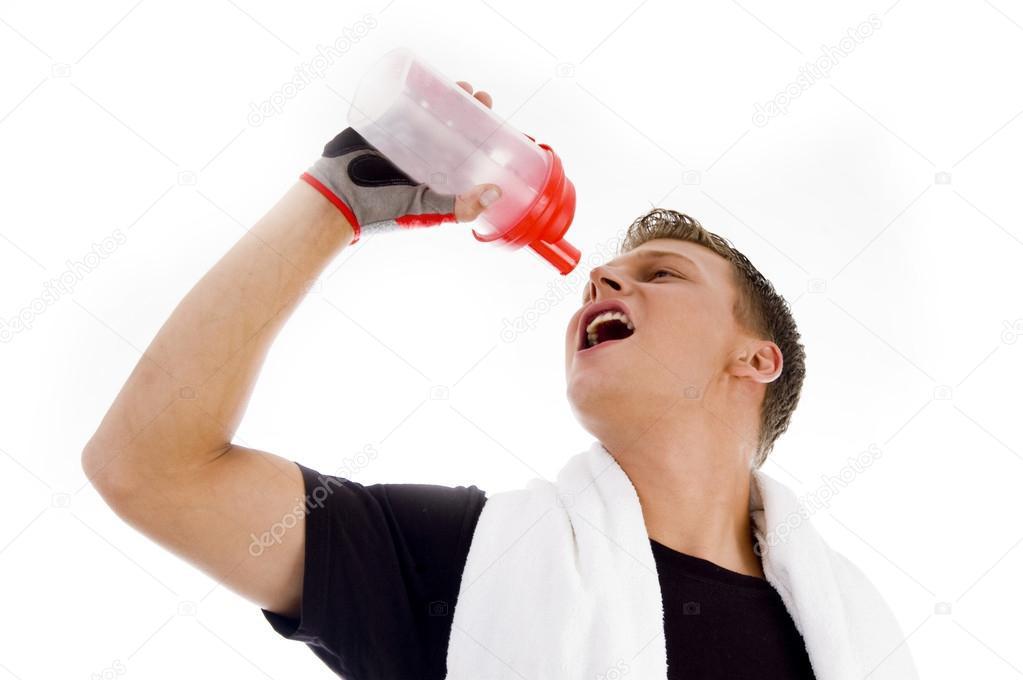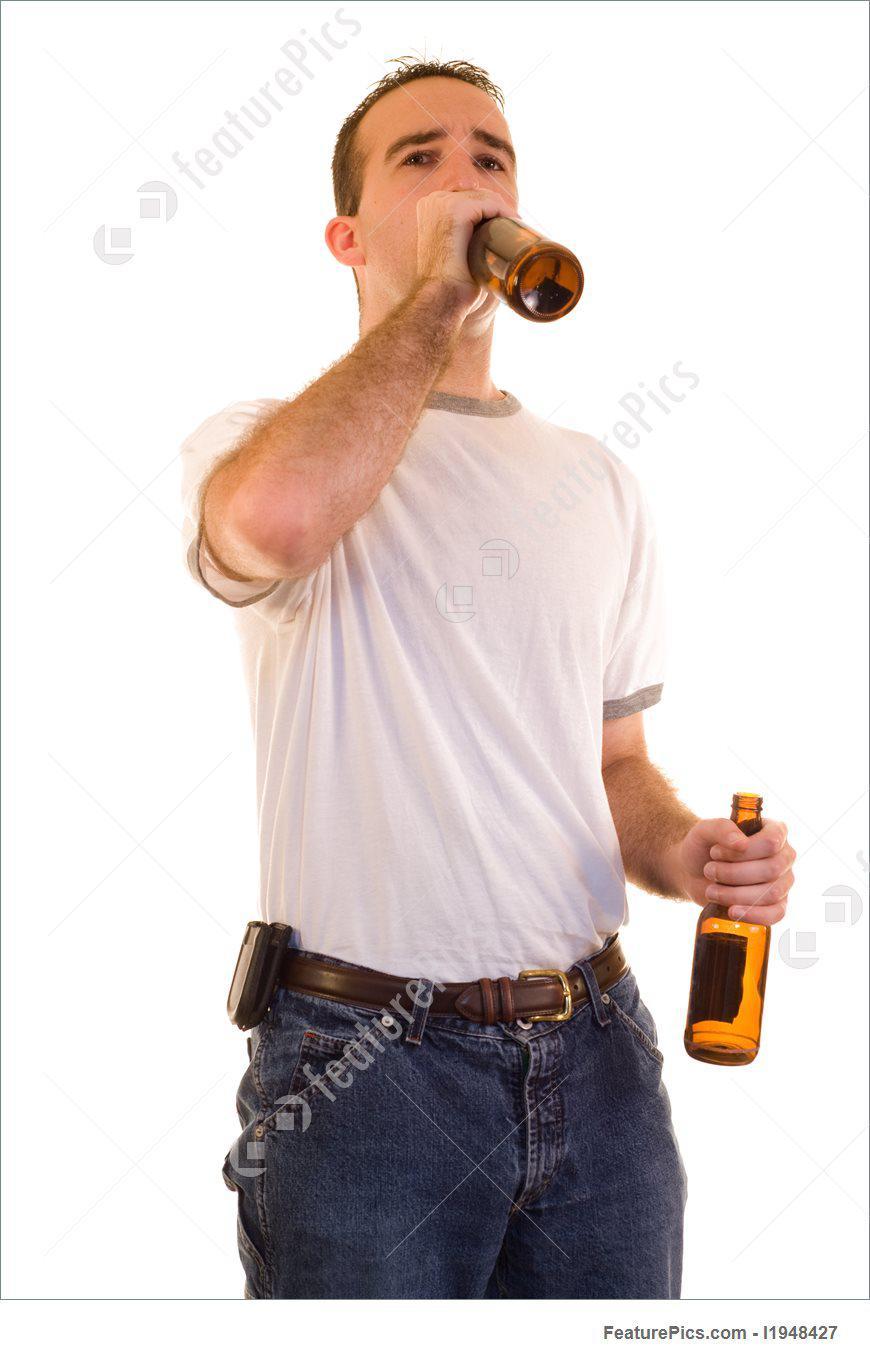The first image is the image on the left, the second image is the image on the right. Assess this claim about the two images: "A person is holding a bottle above his open mouth.". Correct or not? Answer yes or no. Yes. 